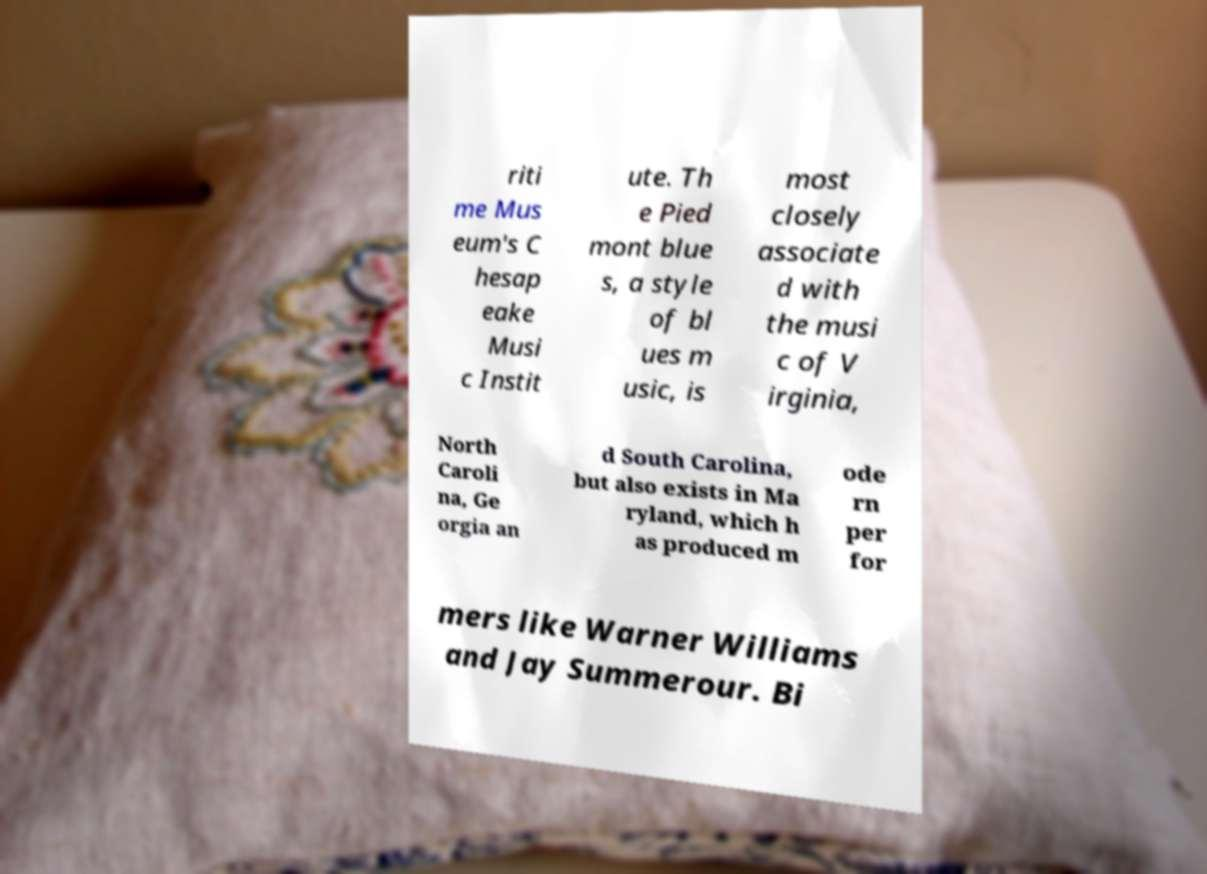Can you accurately transcribe the text from the provided image for me? riti me Mus eum's C hesap eake Musi c Instit ute. Th e Pied mont blue s, a style of bl ues m usic, is most closely associate d with the musi c of V irginia, North Caroli na, Ge orgia an d South Carolina, but also exists in Ma ryland, which h as produced m ode rn per for mers like Warner Williams and Jay Summerour. Bi 